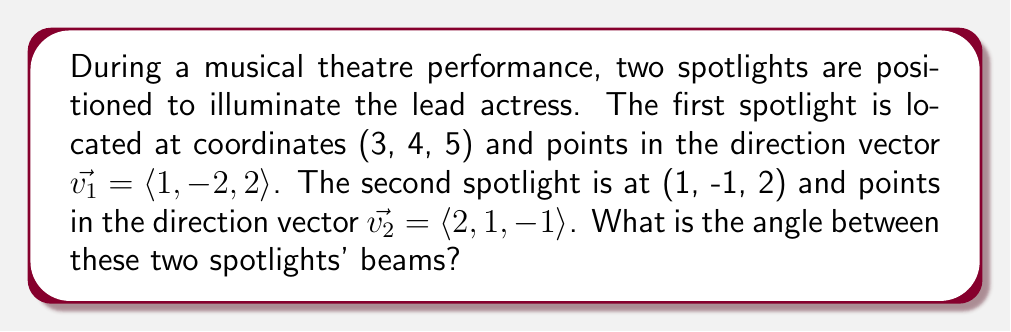Teach me how to tackle this problem. To find the angle between two vectors in 3D space, we can use the dot product formula:

$$\cos \theta = \frac{\vec{v_1} \cdot \vec{v_2}}{|\vec{v_1}| |\vec{v_2}|}$$

Where $\theta$ is the angle between the vectors.

Step 1: Calculate the dot product of $\vec{v_1}$ and $\vec{v_2}$
$$\vec{v_1} \cdot \vec{v_2} = (1)(2) + (-2)(1) + (2)(-1) = 2 - 2 - 2 = -2$$

Step 2: Calculate the magnitudes of $\vec{v_1}$ and $\vec{v_2}$
$$|\vec{v_1}| = \sqrt{1^2 + (-2)^2 + 2^2} = \sqrt{1 + 4 + 4} = \sqrt{9} = 3$$
$$|\vec{v_2}| = \sqrt{2^2 + 1^2 + (-1)^2} = \sqrt{4 + 1 + 1} = \sqrt{6}$$

Step 3: Substitute into the dot product formula
$$\cos \theta = \frac{-2}{3\sqrt{6}}$$

Step 4: Take the inverse cosine (arccos) of both sides
$$\theta = \arccos\left(\frac{-2}{3\sqrt{6}}\right)$$

Step 5: Calculate the result (in radians)
$$\theta \approx 2.0344 \text{ radians}$$

Step 6: Convert to degrees
$$\theta \approx 116.57°$$
Answer: $116.57°$ 